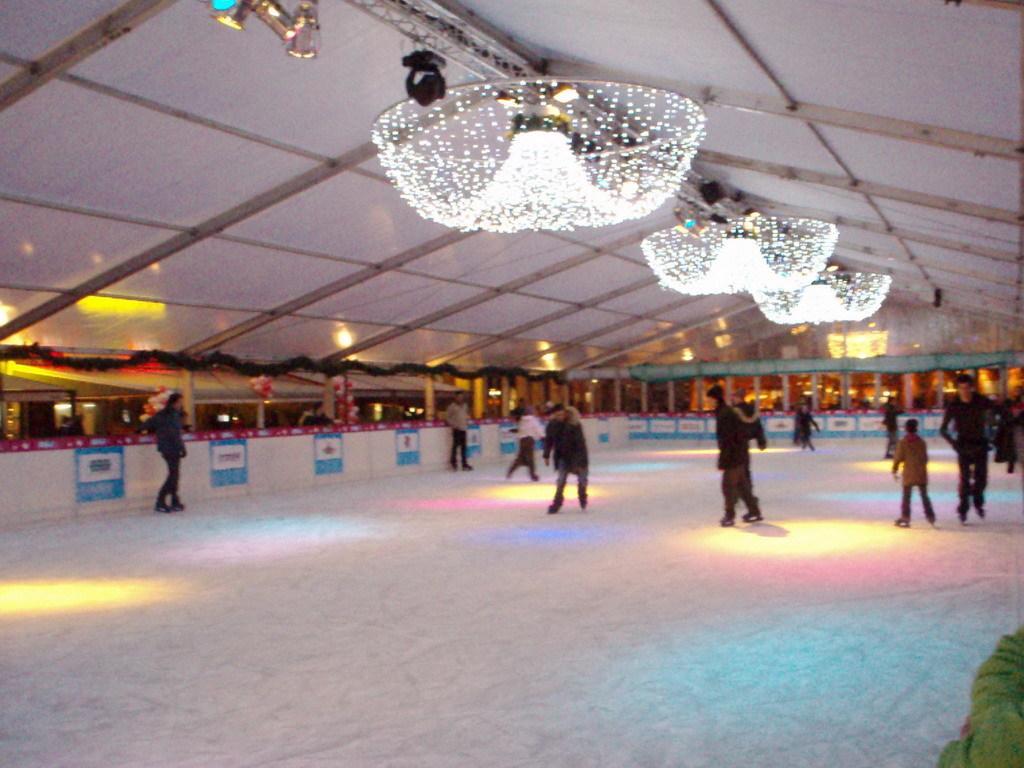Please provide a concise description of this image. This picture shows the inner view of an ice rink. There are so many persons doing ice skating, some objects are on the surface, some objects and some big lights are attached to the ceiling. There are some objects attached to the wall. 